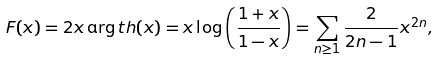Convert formula to latex. <formula><loc_0><loc_0><loc_500><loc_500>F ( x ) = 2 x \arg t h ( x ) = x \log \left ( \frac { 1 + x } { 1 - x } \right ) = \sum _ { n \geq 1 } \frac { 2 } { 2 n - 1 } x ^ { 2 n } ,</formula> 